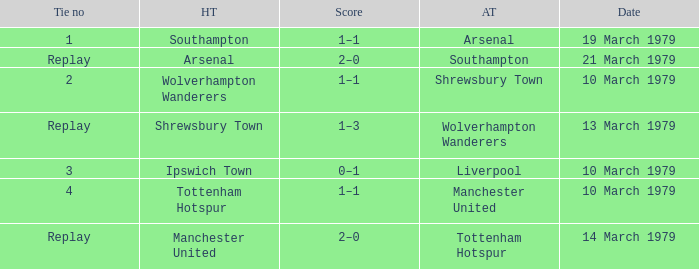Which tie number had an away team of Arsenal? 1.0. 